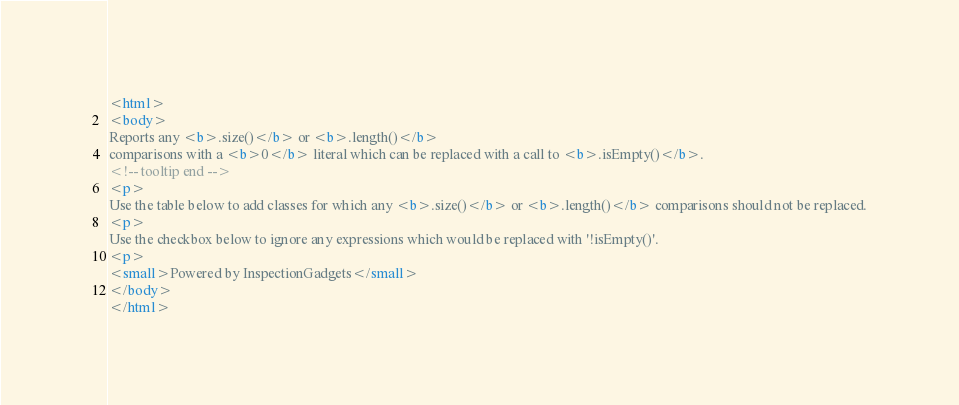Convert code to text. <code><loc_0><loc_0><loc_500><loc_500><_HTML_><html>
<body>
Reports any <b>.size()</b> or <b>.length()</b>
comparisons with a <b>0</b> literal which can be replaced with a call to <b>.isEmpty()</b>.
<!-- tooltip end -->
<p>
Use the table below to add classes for which any <b>.size()</b> or <b>.length()</b> comparisons should not be replaced.
<p>
Use the checkbox below to ignore any expressions which would be replaced with '!isEmpty()'.
<p>
<small>Powered by InspectionGadgets</small>
</body>
</html></code> 